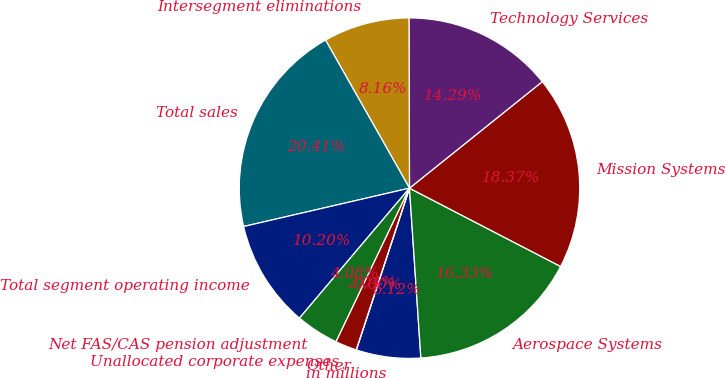<chart> <loc_0><loc_0><loc_500><loc_500><pie_chart><fcel>in millions<fcel>Aerospace Systems<fcel>Mission Systems<fcel>Technology Services<fcel>Intersegment eliminations<fcel>Total sales<fcel>Total segment operating income<fcel>Net FAS/CAS pension adjustment<fcel>Unallocated corporate expenses<fcel>Other<nl><fcel>6.12%<fcel>16.32%<fcel>18.36%<fcel>14.28%<fcel>8.16%<fcel>20.4%<fcel>10.2%<fcel>4.08%<fcel>2.04%<fcel>0.0%<nl></chart> 